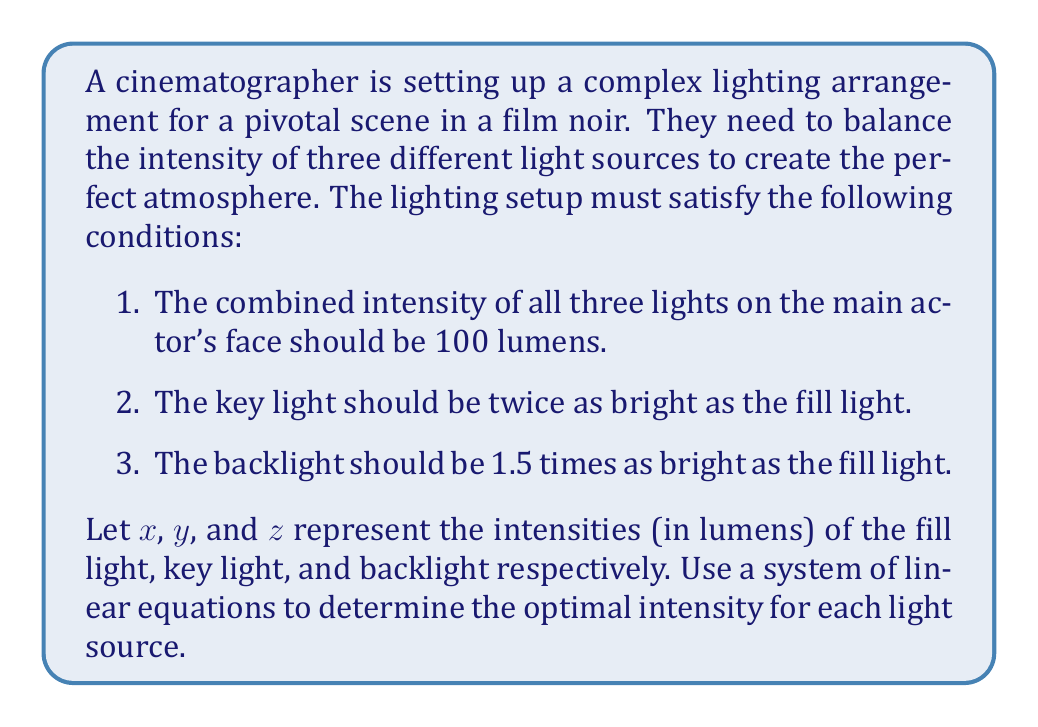Provide a solution to this math problem. To solve this problem, we need to translate the given conditions into a system of linear equations:

1. The combined intensity equation:
   $$x + y + z = 100$$

2. The key light being twice as bright as the fill light:
   $$y = 2x$$

3. The backlight being 1.5 times as bright as the fill light:
   $$z = 1.5x$$

Now we have a system of three equations with three unknowns:

$$\begin{cases}
x + y + z = 100 \\
y = 2x \\
z = 1.5x
\end{cases}$$

Let's solve this system by substitution:

1. Substitute the expressions for $y$ and $z$ into the first equation:
   $$x + 2x + 1.5x = 100$$
   $$4.5x = 100$$

2. Solve for $x$:
   $$x = \frac{100}{4.5} \approx 22.22$$

3. Now that we know $x$, we can calculate $y$ and $z$:
   $$y = 2x = 2(22.22) \approx 44.44$$
   $$z = 1.5x = 1.5(22.22) \approx 33.33$$

4. Let's verify that these values satisfy the original equation:
   $$22.22 + 44.44 + 33.33 \approx 99.99$$
   (The slight discrepancy is due to rounding)

Therefore, the optimal intensities for each light source are:
- Fill light (x): 22.22 lumens
- Key light (y): 44.44 lumens
- Backlight (z): 33.33 lumens
Answer: Fill light: 22.22 lumens
Key light: 44.44 lumens
Backlight: 33.33 lumens 